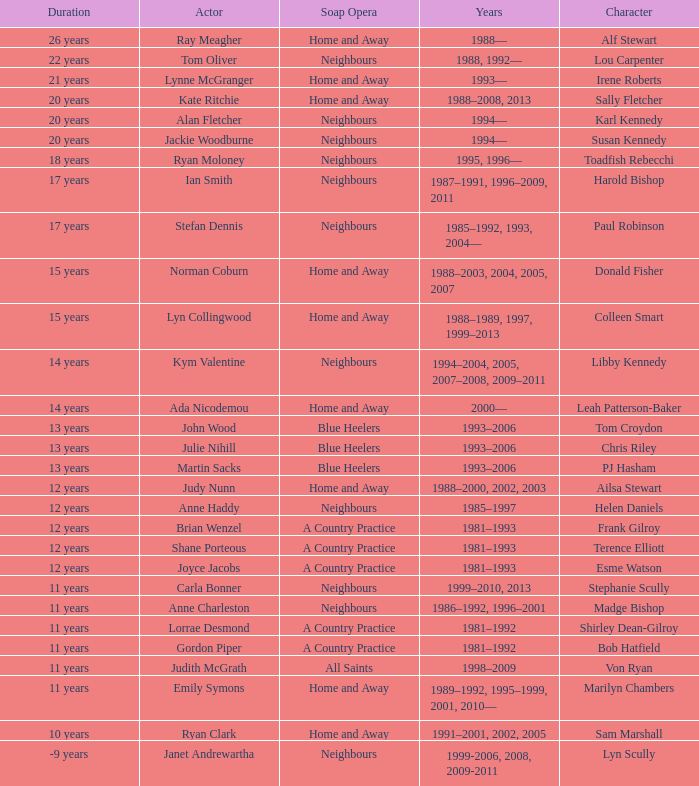What character was portrayed by the same actor for 12 years on Neighbours? Helen Daniels. 